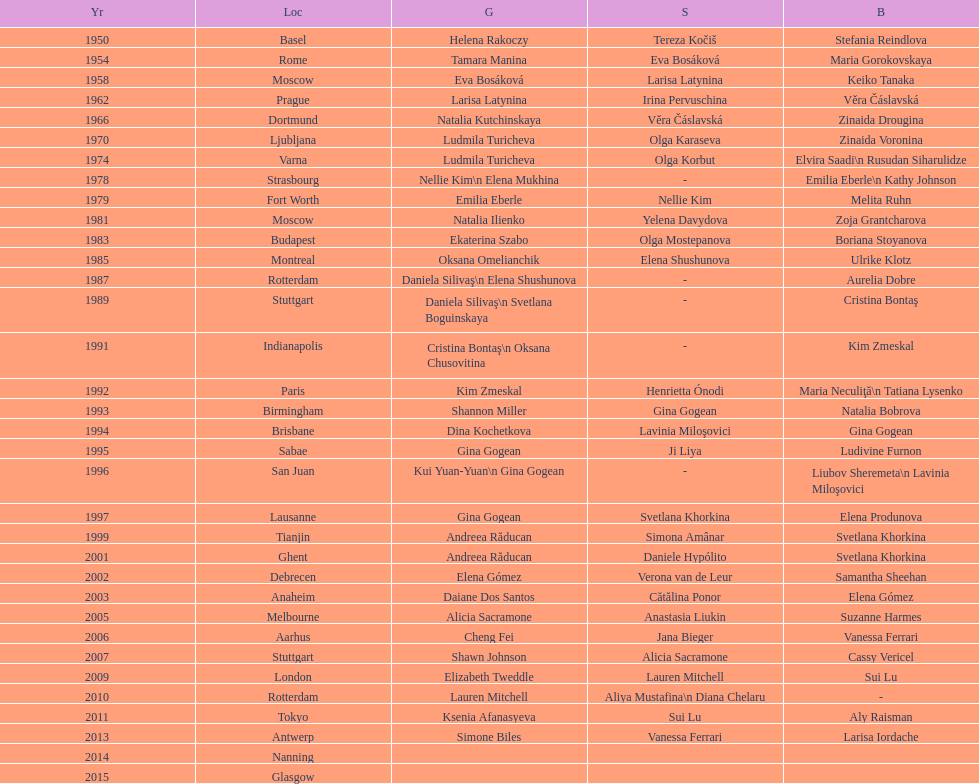How many consecutive floor exercise gold medals did romanian star andreea raducan win at the world championships? 2. 